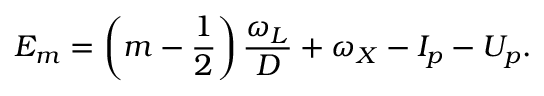Convert formula to latex. <formula><loc_0><loc_0><loc_500><loc_500>E _ { m } = \left ( m - \frac { 1 } { 2 } \right ) \frac { \omega _ { L } } { D } + \omega _ { X } - I _ { p } - U _ { p } .</formula> 